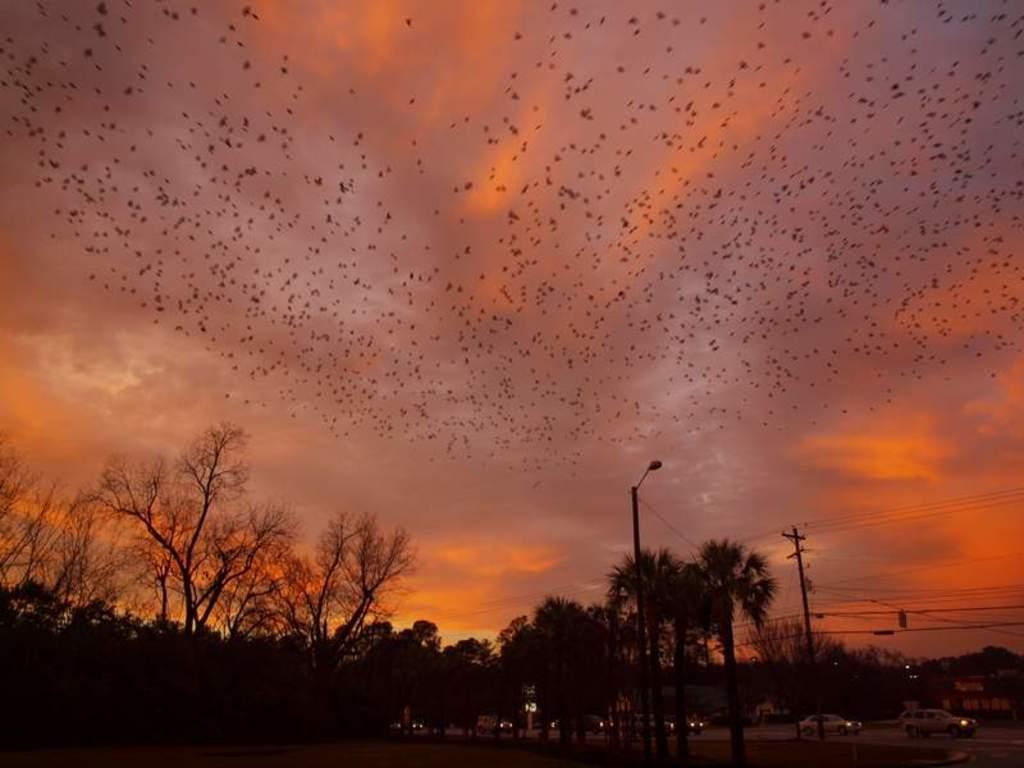In one or two sentences, can you explain what this image depicts? At the bottom of the image there are trees, light poles. At the top of the image there are birds in sky and clouds. There are cars on the road. 